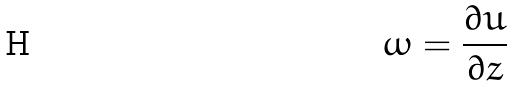<formula> <loc_0><loc_0><loc_500><loc_500>\omega = \frac { \partial u } { \partial z }</formula> 